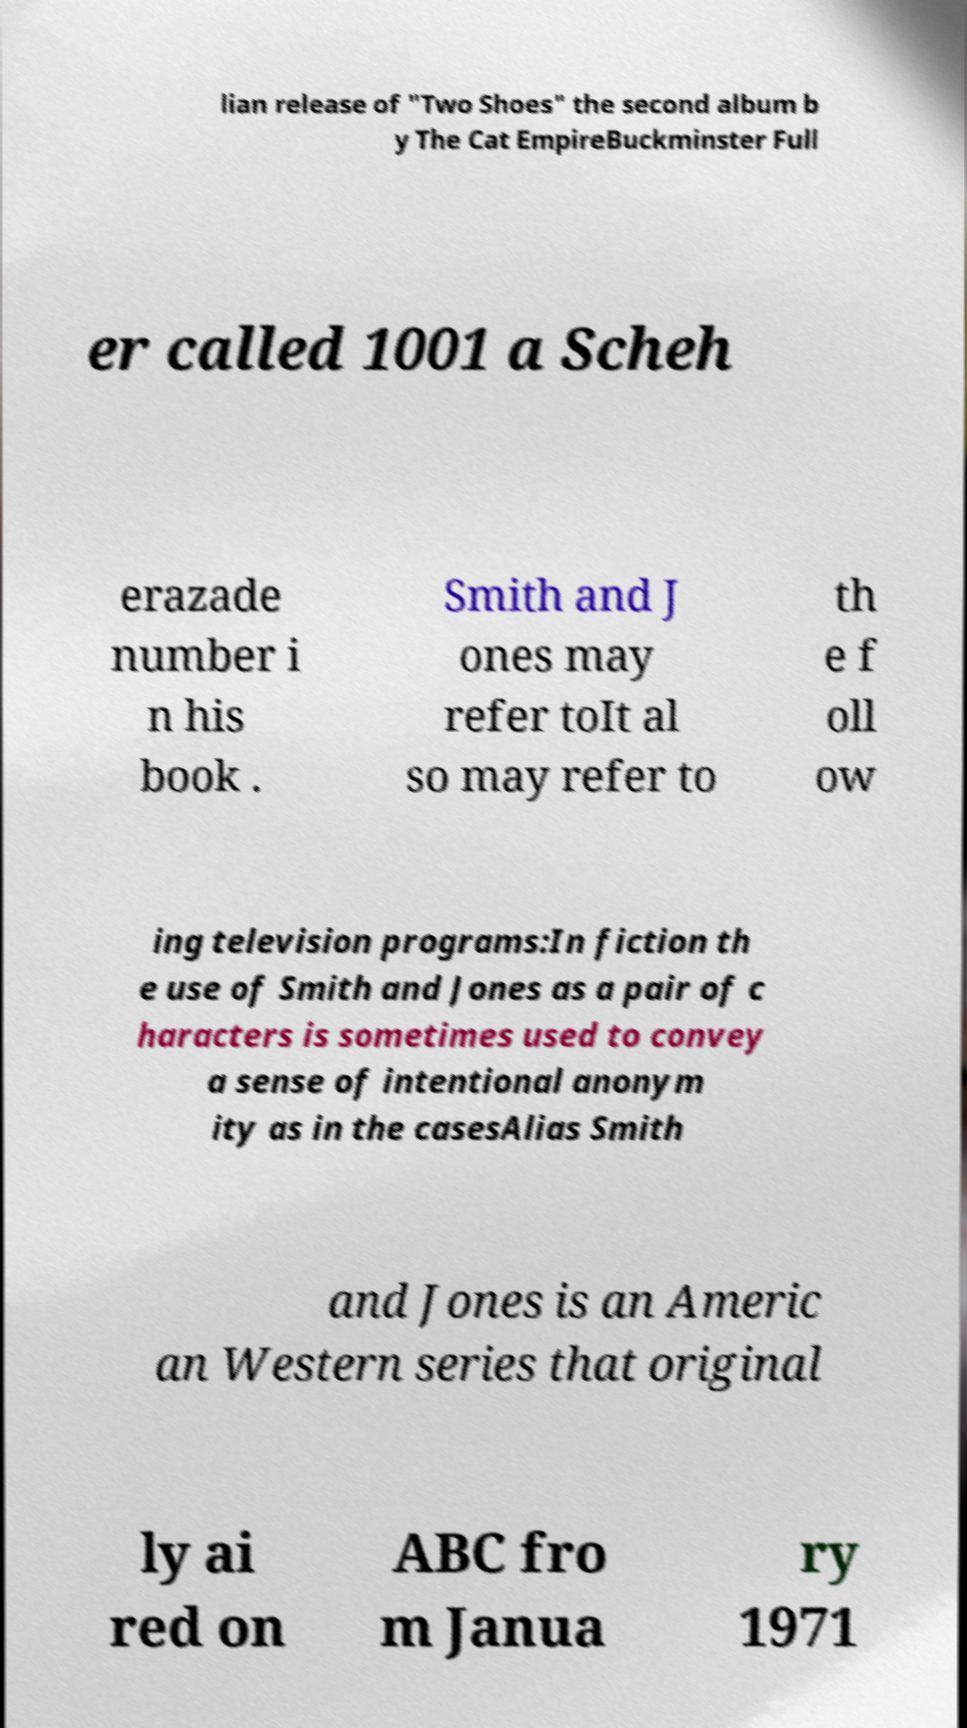Please identify and transcribe the text found in this image. lian release of "Two Shoes" the second album b y The Cat EmpireBuckminster Full er called 1001 a Scheh erazade number i n his book . Smith and J ones may refer toIt al so may refer to th e f oll ow ing television programs:In fiction th e use of Smith and Jones as a pair of c haracters is sometimes used to convey a sense of intentional anonym ity as in the casesAlias Smith and Jones is an Americ an Western series that original ly ai red on ABC fro m Janua ry 1971 